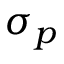<formula> <loc_0><loc_0><loc_500><loc_500>\sigma _ { p }</formula> 